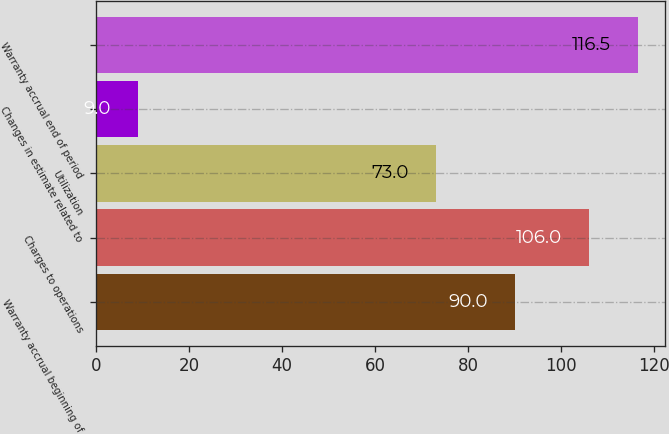<chart> <loc_0><loc_0><loc_500><loc_500><bar_chart><fcel>Warranty accrual beginning of<fcel>Charges to operations<fcel>Utilization<fcel>Changes in estimate related to<fcel>Warranty accrual end of period<nl><fcel>90<fcel>106<fcel>73<fcel>9<fcel>116.5<nl></chart> 